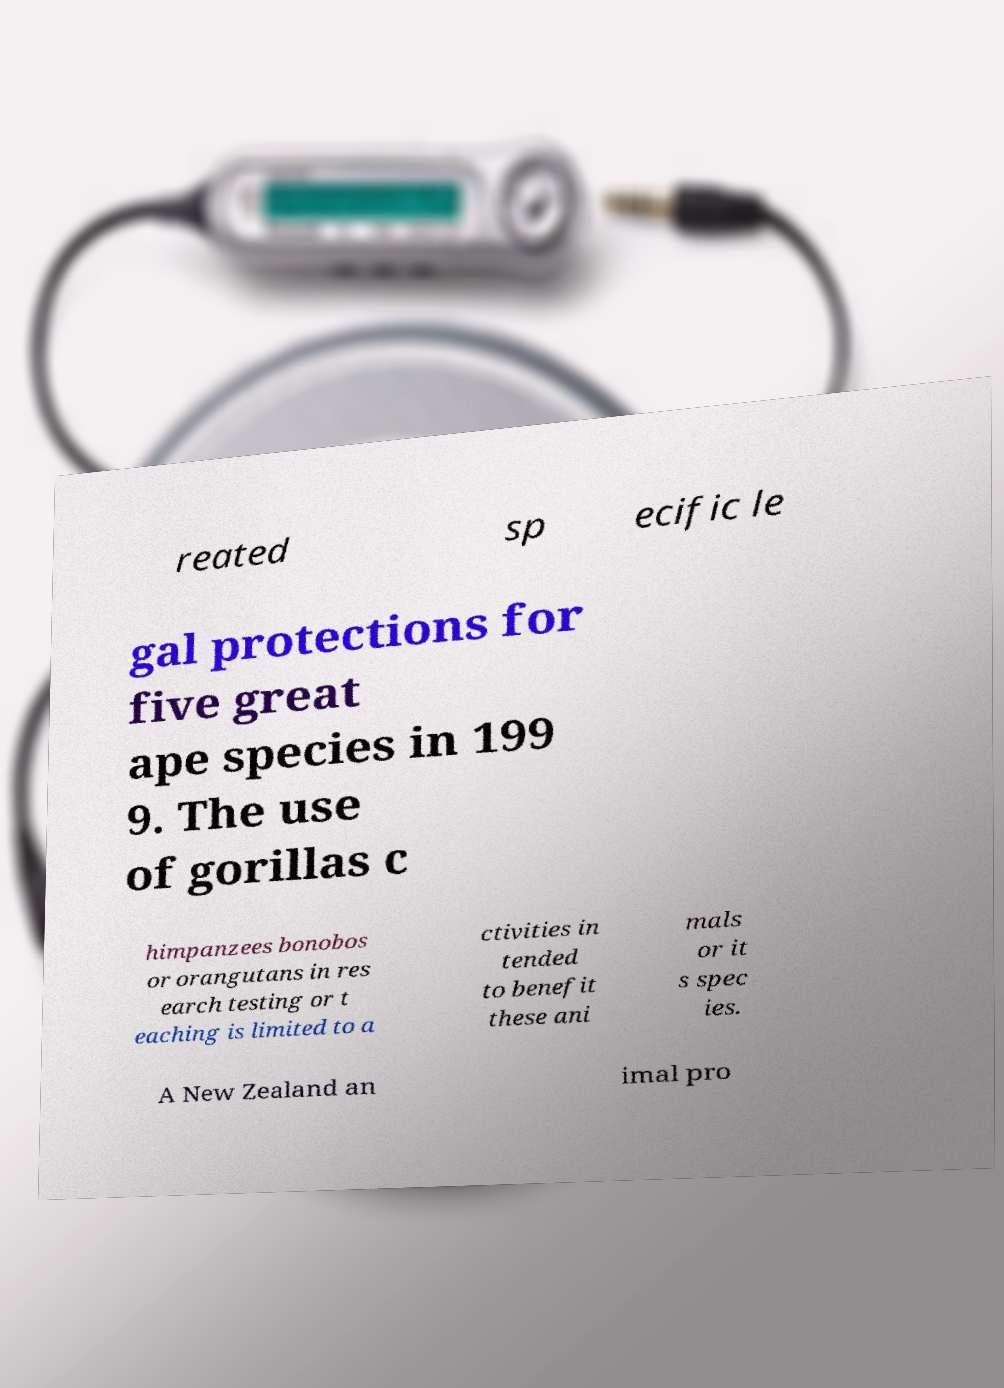Please identify and transcribe the text found in this image. reated sp ecific le gal protections for five great ape species in 199 9. The use of gorillas c himpanzees bonobos or orangutans in res earch testing or t eaching is limited to a ctivities in tended to benefit these ani mals or it s spec ies. A New Zealand an imal pro 